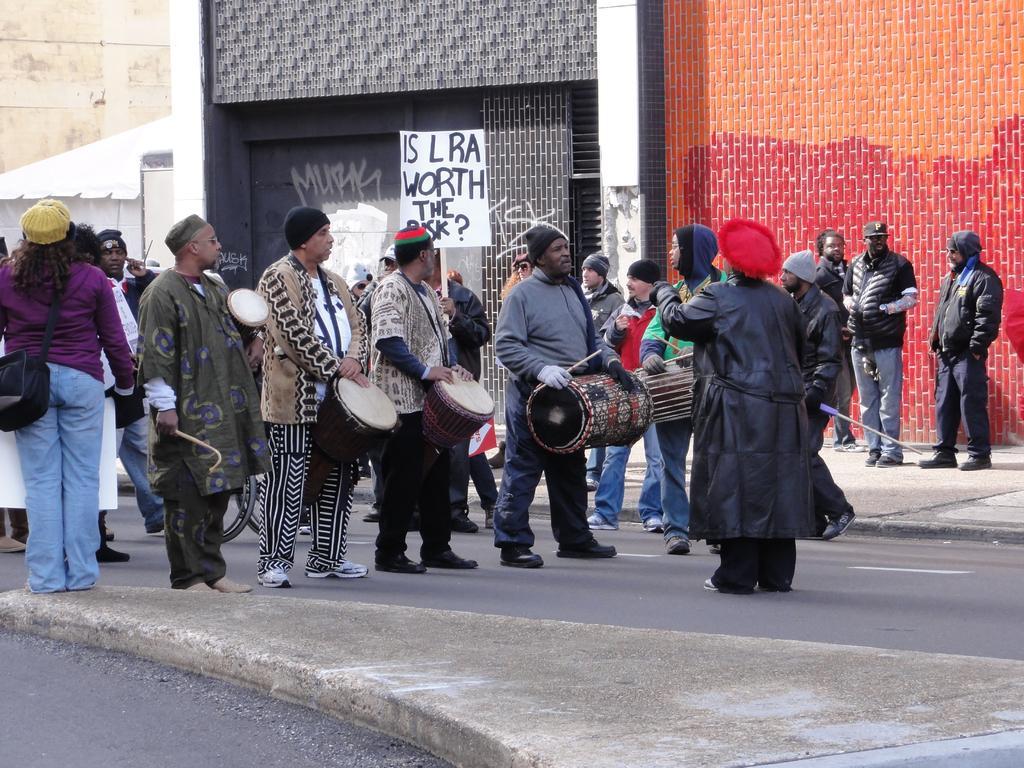Please provide a concise description of this image. In the image we can see there are lot of people who are standing on the road by holding drums in their hand. 